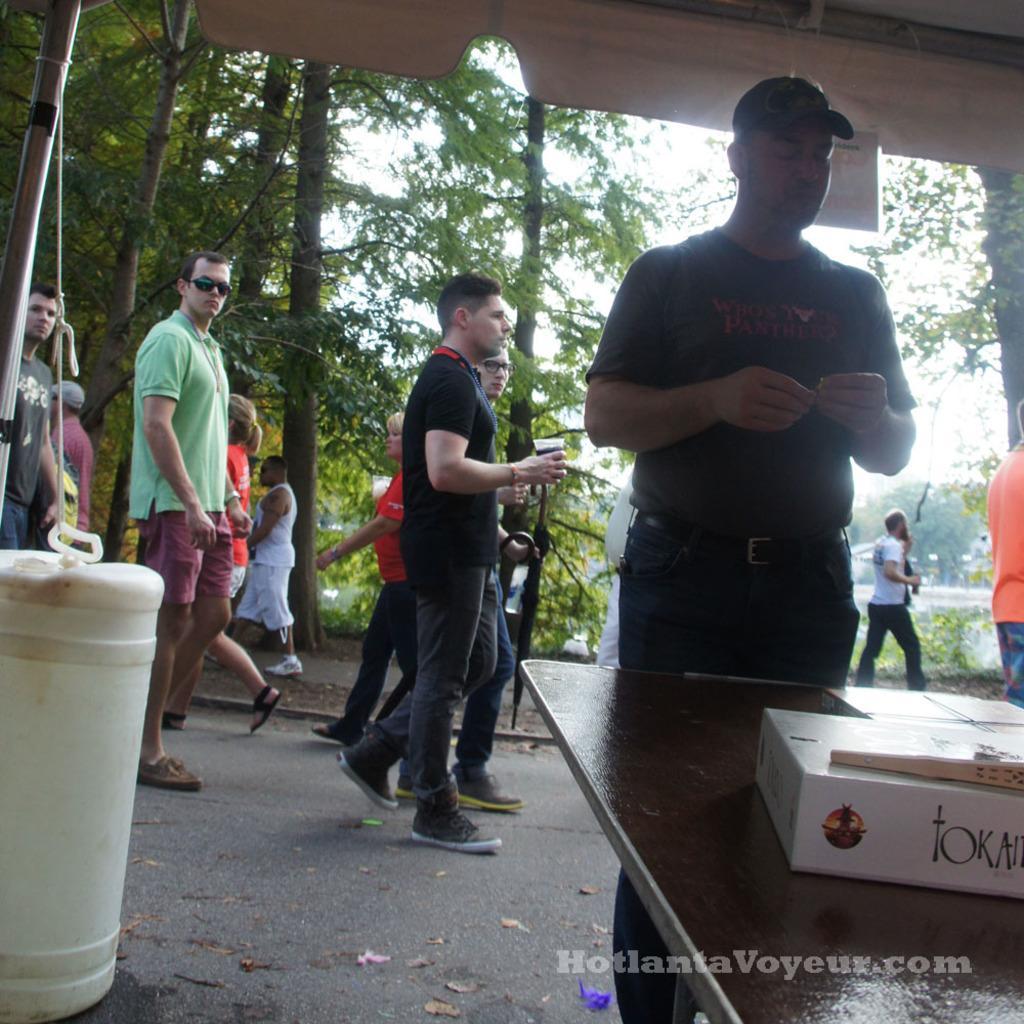In one or two sentences, can you explain what this image depicts? In this picture we can see people on the ground, one person is holding a glass, here we can see a table, box, water can, roof and some objects and in the background we can see trees, sky, in the bottom right we can see some text on it. 